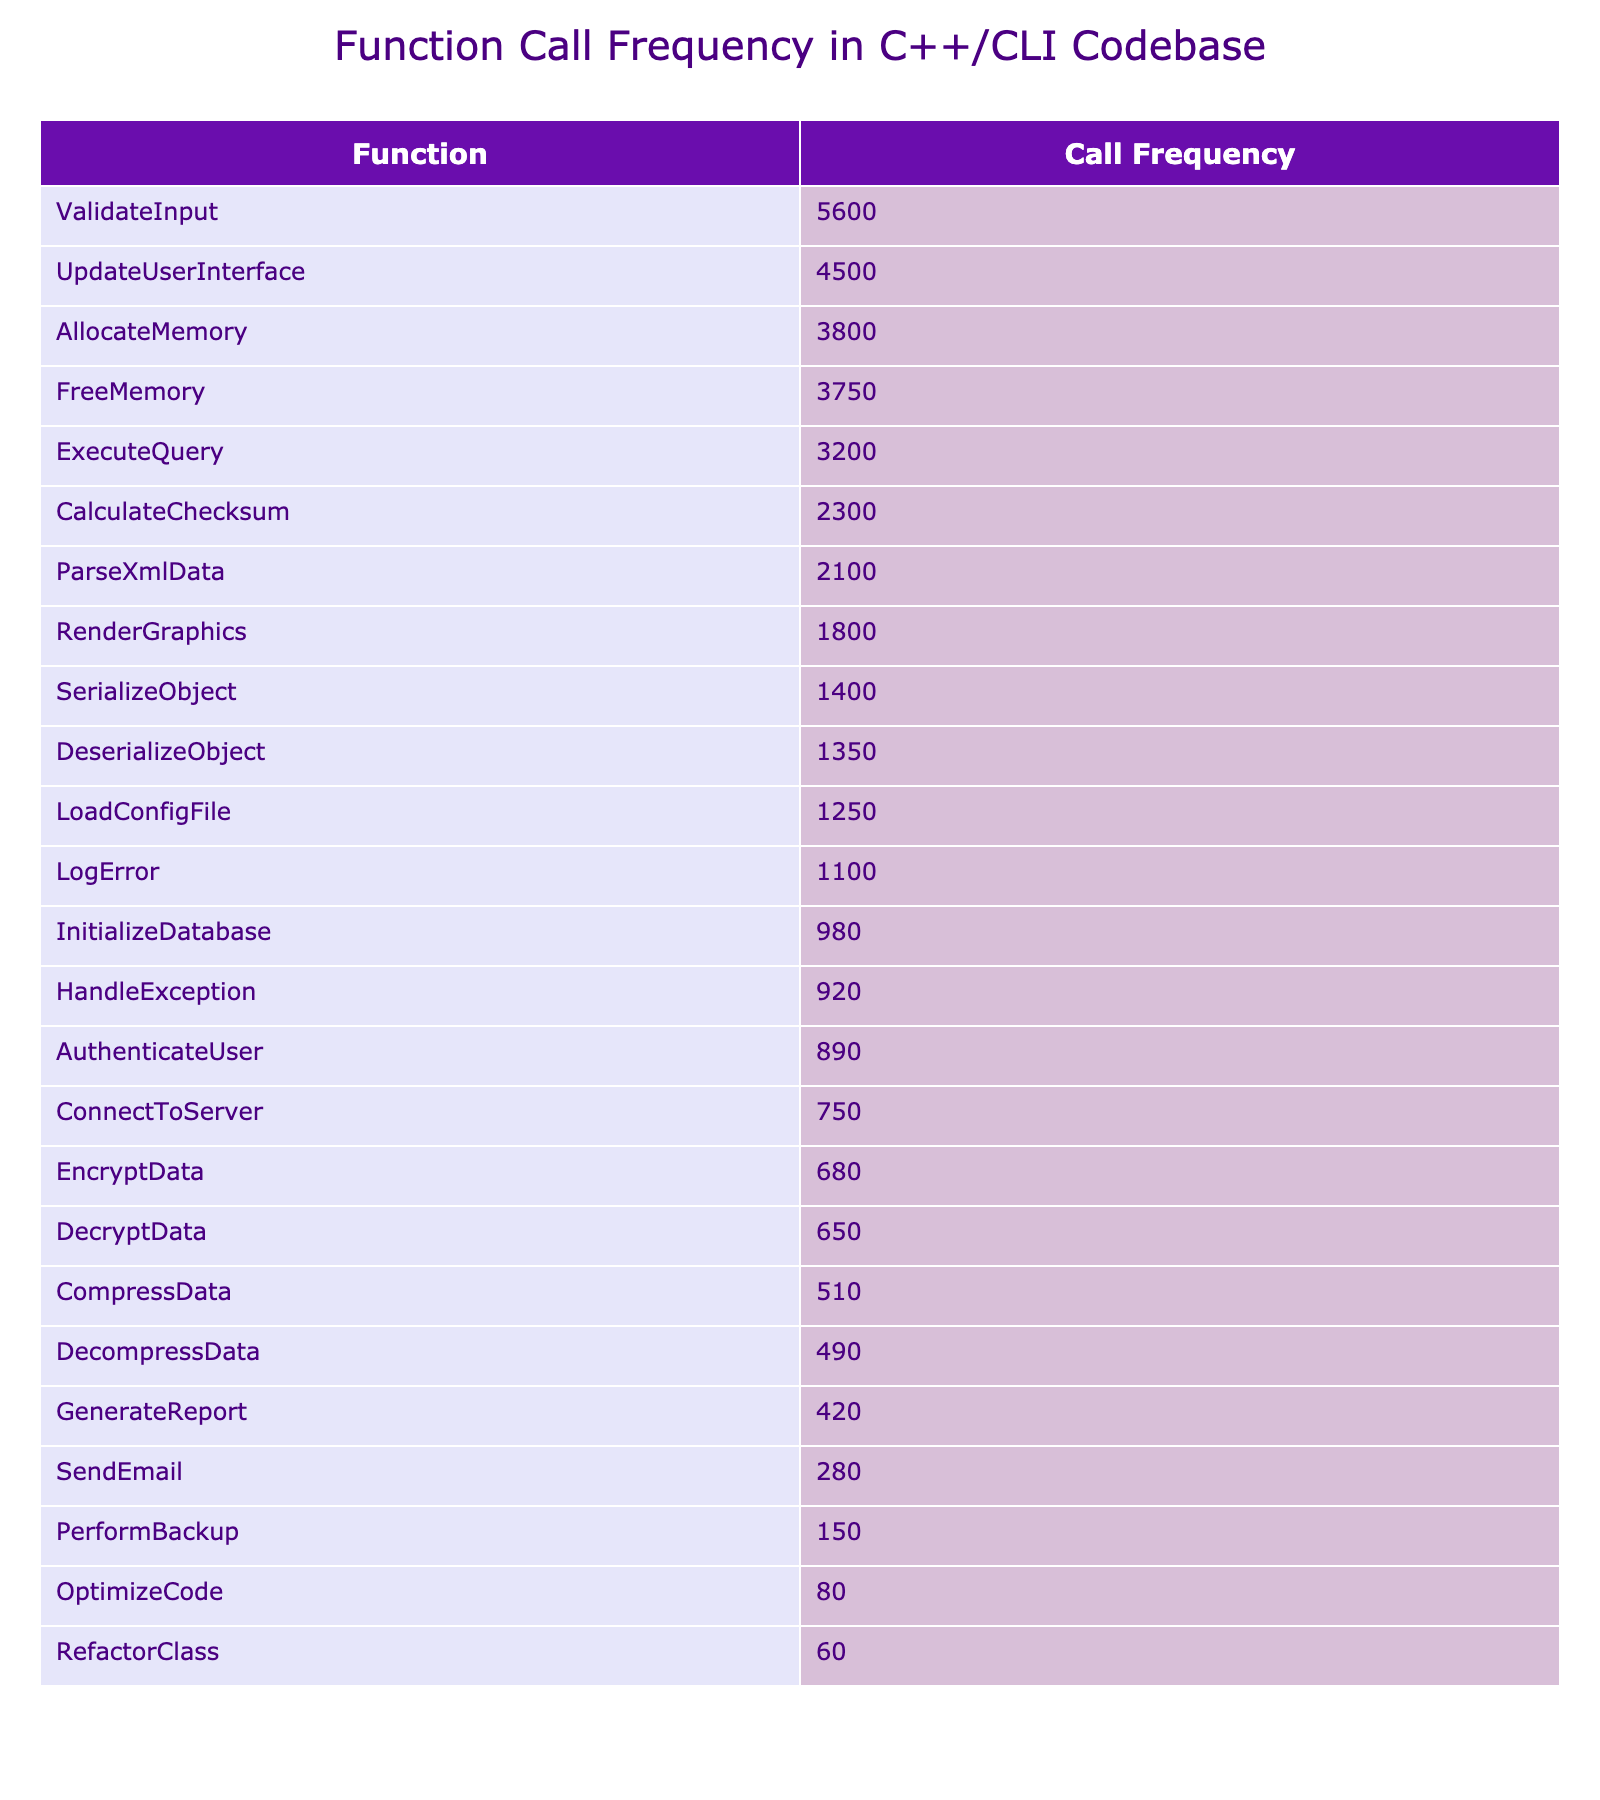What is the function with the highest call frequency? By examining the table, the function "ValidateInput" has the highest call frequency at 5600 calls.
Answer: ValidateInput How many calls does "LoadConfigFile" have compared to "SendEmail"? "LoadConfigFile" has 1250 calls and "SendEmail" has 280 calls, so it has 1250 - 280 = 970 more calls.
Answer: 970 What is the total call frequency for all functions listed? By adding all the call frequencies together: 1250 + 980 + 2100 + 4500 + 750 + 3200 + 5600 + 1800 + 920 + 1100 + 3800 + 3750 + 680 + 650 + 1400 + 1350 + 2300 + 510 + 490 + 890 + 420 + 280 + 150 + 80 + 60 = 25460.
Answer: 25460 Is "CompressData" called more frequently than "DecompressData"? "CompressData" has 510 calls and "DecompressData" has 490 calls, thus "CompressData" is called more frequently.
Answer: Yes What is the average call frequency for the functions that deal with data serialization and deserialization? The functions "SerializeObject" (1400 calls) and "DeserializeObject" (1350 calls) both relate to serialization. The total is 1400 + 1350 = 2750, and the average is 2750 / 2 = 1375.
Answer: 1375 Which function has the least call frequency and what is its frequency? The function with the least call frequency is "RefactorClass" with only 60 calls noted in the table.
Answer: RefactorClass, 60 How many functions have a call frequency greater than 2000? By checking the frequencies, the functions are: ParseXmlData (2100), UpdateUserInterface (4500), ExecuteQuery (3200), ValidateInput (5600), AllocateMemory (3800), FreeMemory (3750), CalculateChecksum (2300). There are 7 such functions.
Answer: 7 What percentage of the total call frequency do the top three functions contribute? The top three functions based on call frequency are: ValidateInput (5600), UpdateUserInterface (4500), ExecuteQuery (3200). Their total is 5600 + 4500 + 3200 = 13300. The percentage is (13300/25460) * 100 ≈ 52.3%.
Answer: 52.3% What is the difference in call frequency between the function with the highest frequency and the one with the lowest? "ValidateInput" has the highest call frequency of 5600, while "RefactorClass" has the lowest at 60. The difference is 5600 - 60 = 5540.
Answer: 5540 Are there any functions that have a call frequency of less than 100? A review of the table shows no function has a call frequency below 60, so the answer is no.
Answer: No 